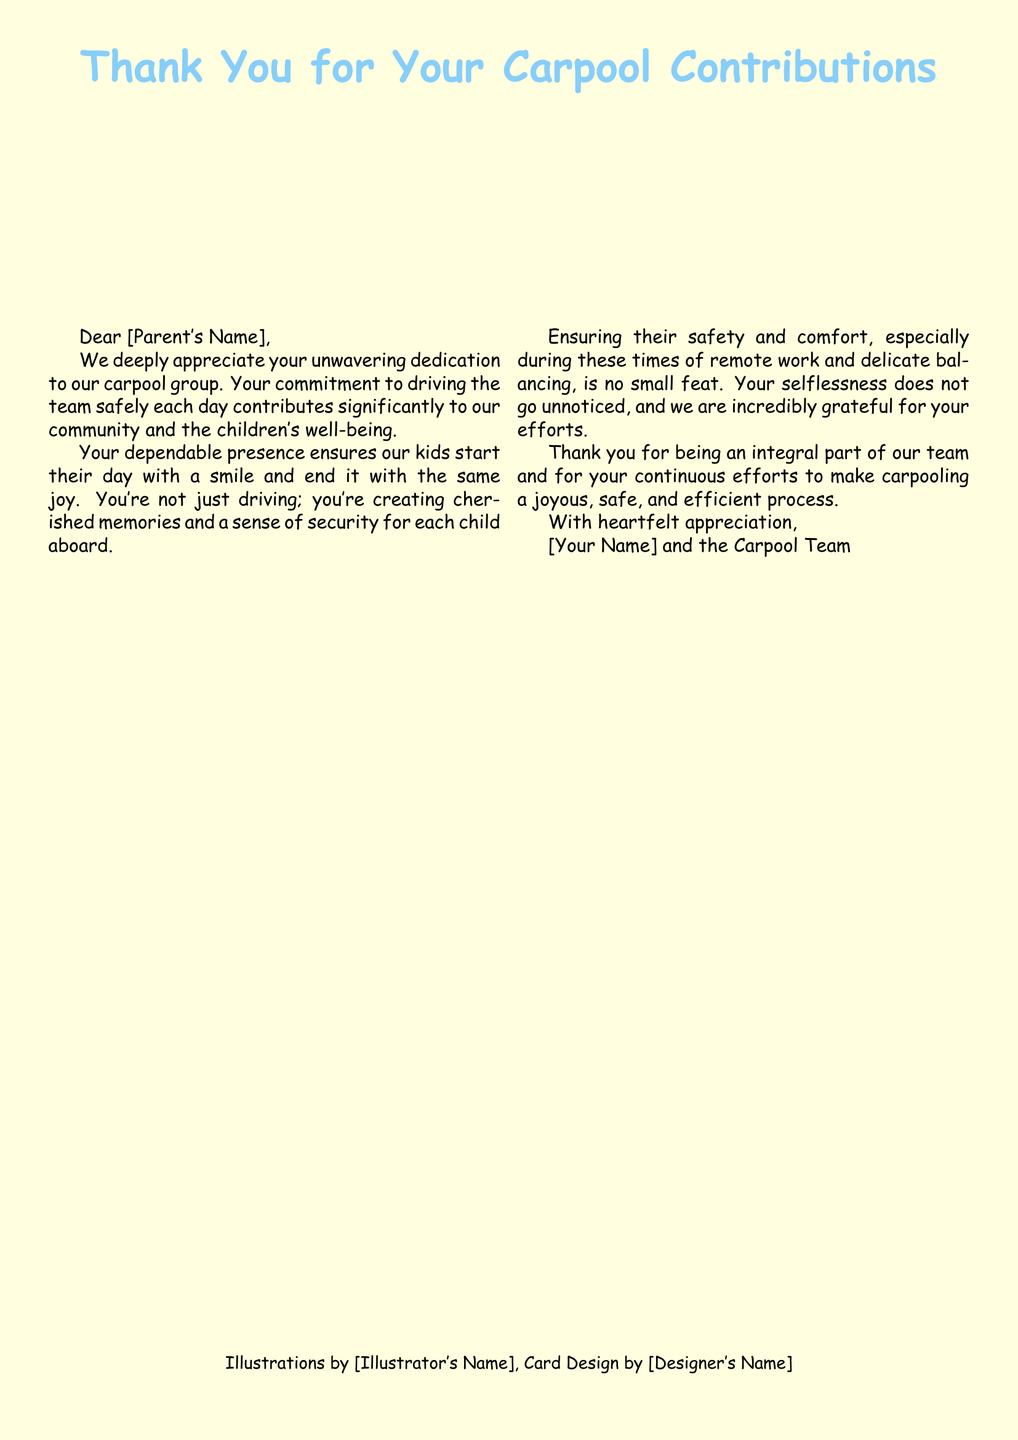What is the main title of the card? The main title of the card expresses gratitude for carpool contributions.
Answer: Thank You for Your Carpool Contributions Who is the message addressed to? The message is directed to people who contribute to the carpool, specifically named parents.
Answer: [Parent's Name] What color is the background of the card? The background color of the card is identified in the document.
Answer: cardyellow What does the illustration depict? The illustration represents the activity of children traveling together, aiming for a joyful depiction.
Answer: kids happily riding in a car Who designed the card? The designer's name is mentioned as part of the card design credit section.
Answer: [Designer's Name] What sentiment is expressed in the message? The primary sentiment conveyed in the message is about appreciation for contributions.
Answer: gratitude How many columns are used in the text layout? The document structure utilizes a specific layout format that divides the message.
Answer: two What is noted to be significant about the parent's role? The message emphasizes a particular aspect regarding the parent's involvement in the carpool process.
Answer: creates cherished memories 